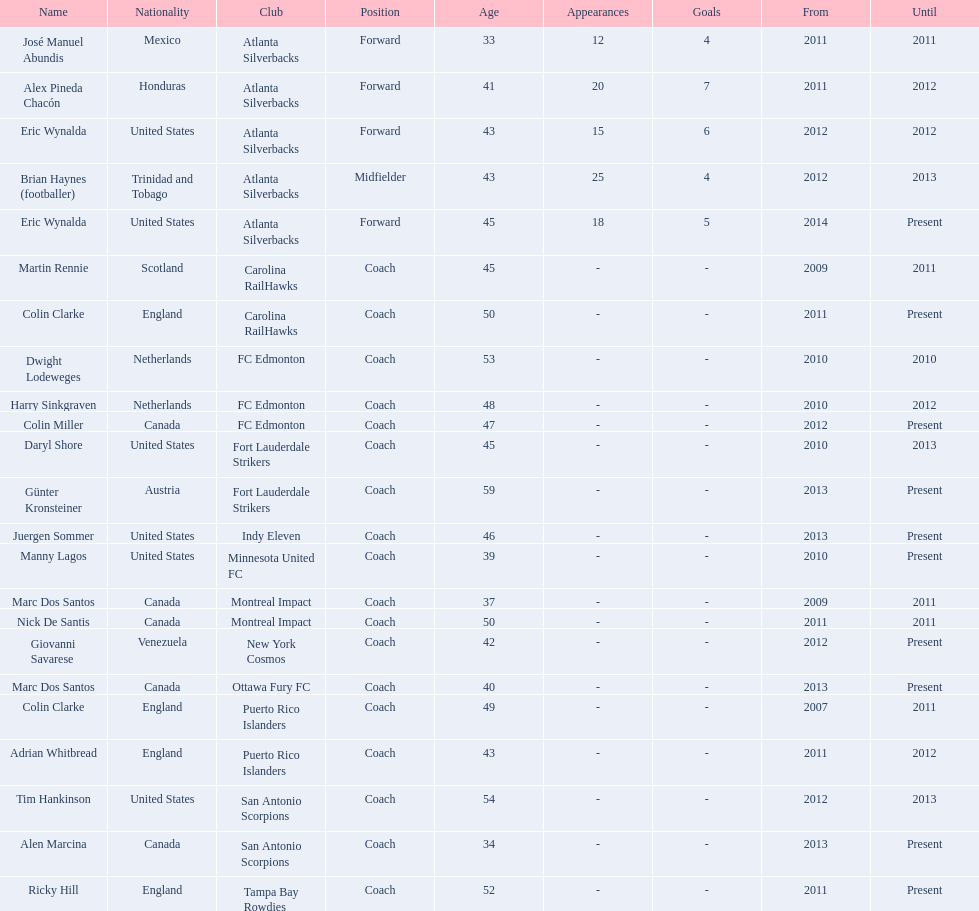How long did colin clarke coach the puerto rico islanders? 4 years. 